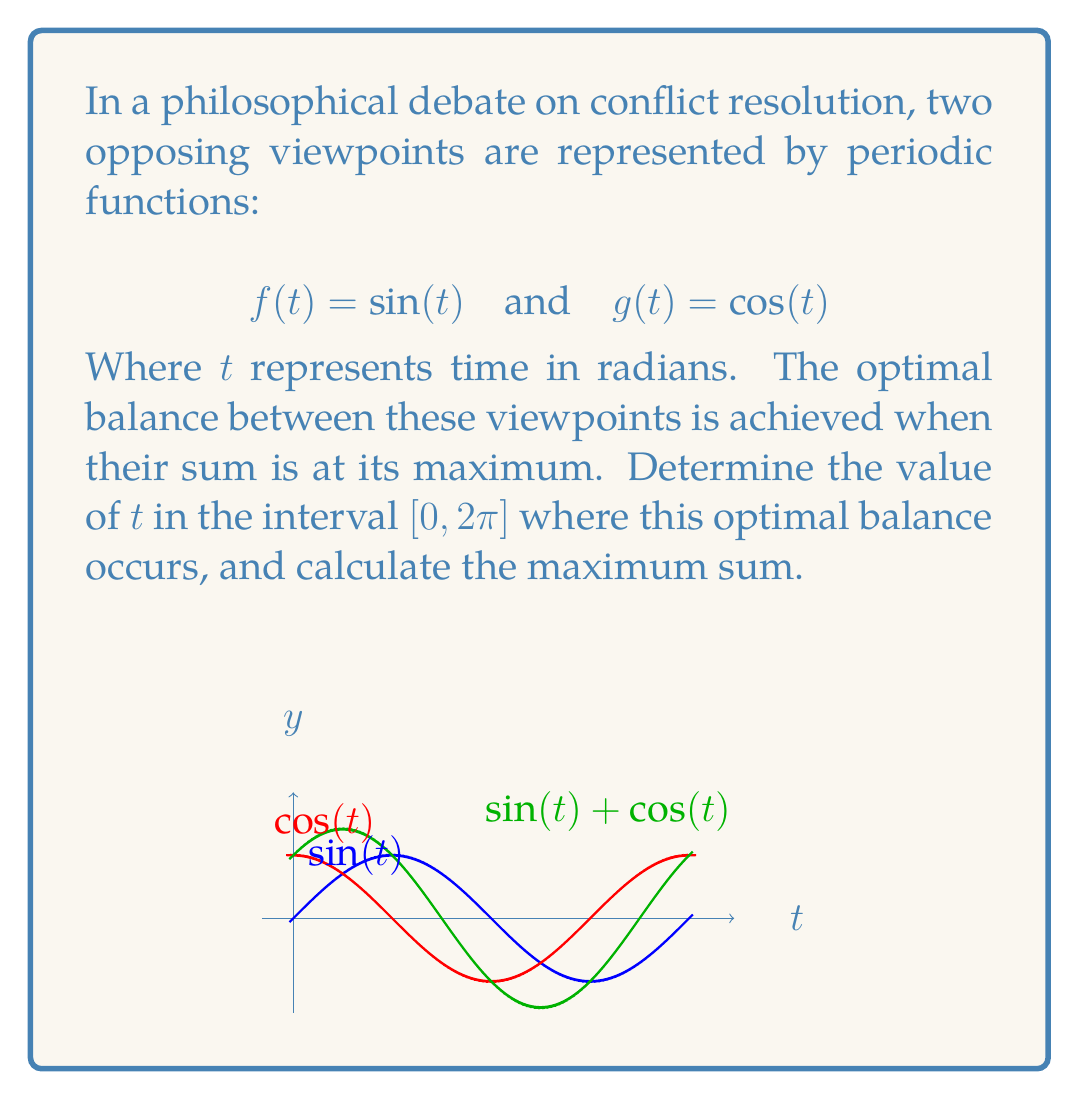Can you solve this math problem? Let's approach this step-by-step:

1) The sum of the two functions is:
   $$h(t) = f(t) + g(t) = \sin(t) + \cos(t)$$

2) To find the maximum of $h(t)$, we need to find where its derivative equals zero:
   $$h'(t) = \cos(t) - \sin(t)$$
   $$h'(t) = 0$$
   $$\cos(t) - \sin(t) = 0$$
   $$\cos(t) = \sin(t)$$

3) This occurs when $t = \frac{\pi}{4}$ (and also at $\frac{5\pi}{4}$, but this is outside our interval).

4) To confirm this is a maximum (not a minimum), we can check the second derivative:
   $$h''(t) = -\sin(t) - \cos(t)$$
   At $t = \frac{\pi}{4}$, $h''(\frac{\pi}{4}) < 0$, confirming it's a maximum.

5) The maximum value of $h(t)$ is:
   $$h(\frac{\pi}{4}) = \sin(\frac{\pi}{4}) + \cos(\frac{\pi}{4}) = \frac{\sqrt{2}}{2} + \frac{\sqrt{2}}{2} = \sqrt{2}$$

Therefore, the optimal balance occurs at $t = \frac{\pi}{4}$, and the maximum sum is $\sqrt{2}$.
Answer: $t = \frac{\pi}{4}$, maximum sum $= \sqrt{2}$ 